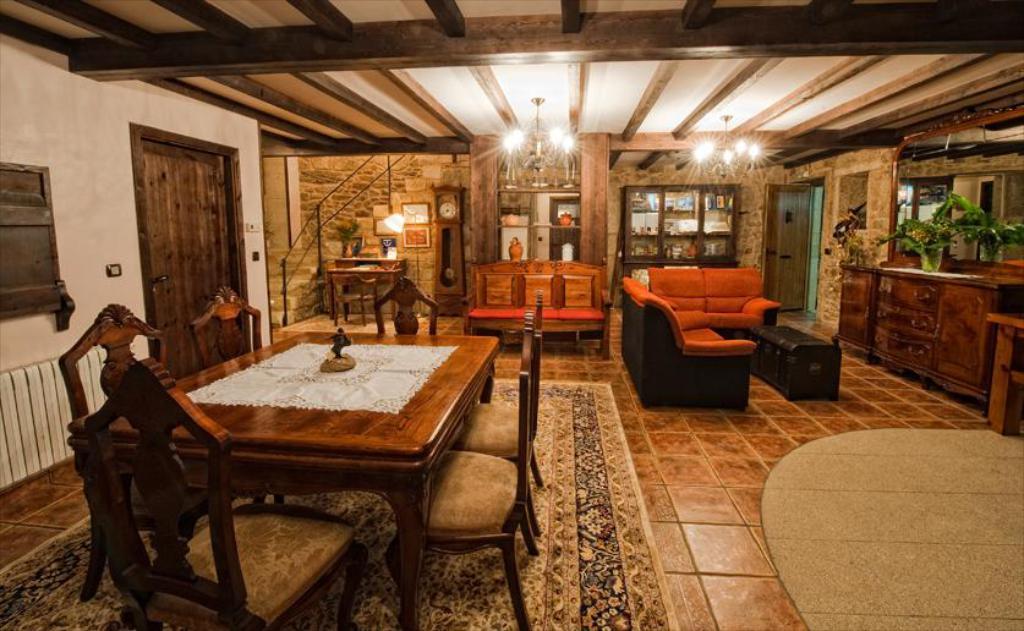Could you give a brief overview of what you see in this image? This is the picture of a room where we have a dining table to the left side and a sofa, a desk on which some things are placed in the right side and behind the sofa there is a shelf in which some things are placed. 